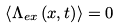Convert formula to latex. <formula><loc_0><loc_0><loc_500><loc_500>\left \langle \Lambda _ { e x } \left ( x , t \right ) \right \rangle = 0</formula> 